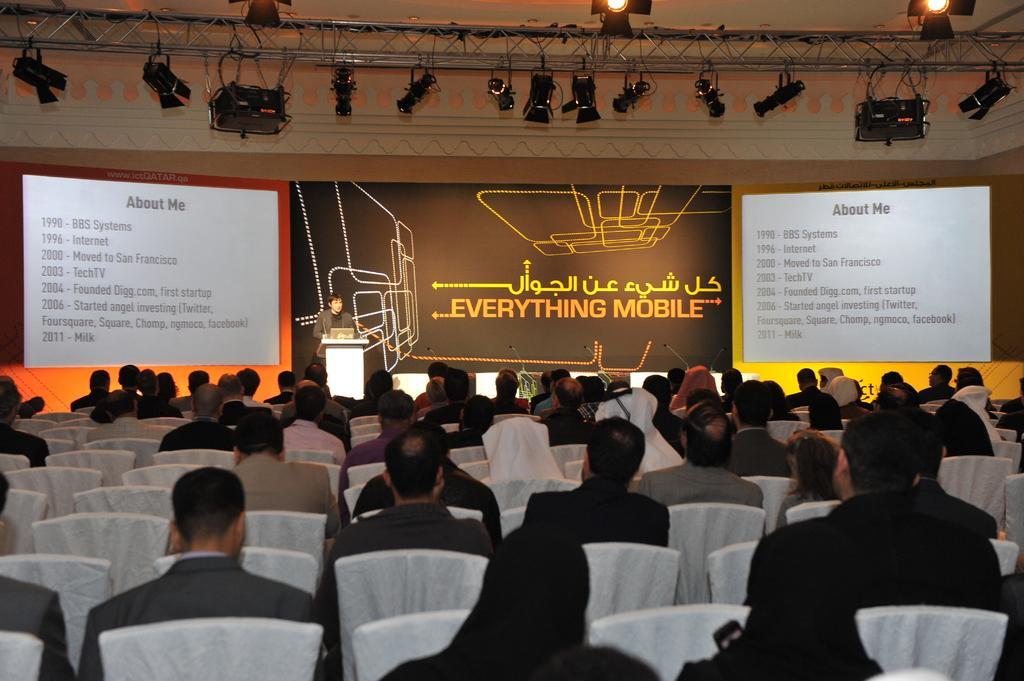Please provide a concise description of this image. In this picture, there are group of people sitting on the chairs. In the center, there is a person standing behind the podium. Towards the left and right, there are boards with some text. In the background, there is a wall with some text. On the top, there are lights. Most of the men are wearing blazers. 